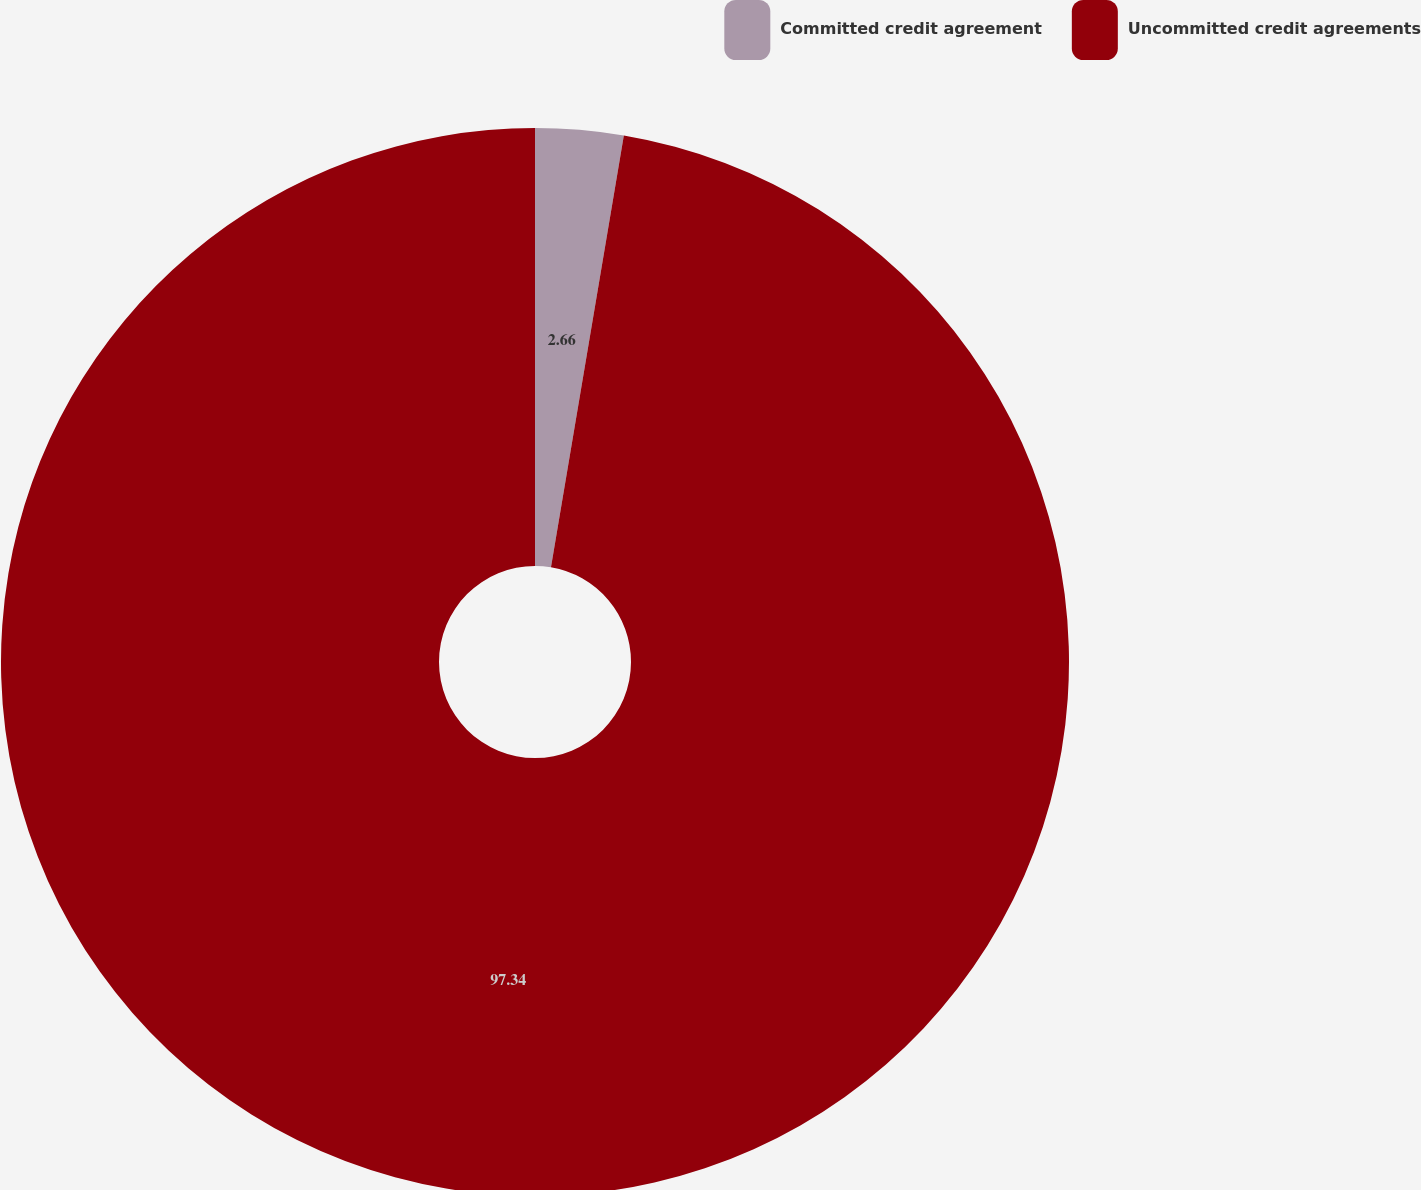Convert chart. <chart><loc_0><loc_0><loc_500><loc_500><pie_chart><fcel>Committed credit agreement<fcel>Uncommitted credit agreements<nl><fcel>2.66%<fcel>97.34%<nl></chart> 